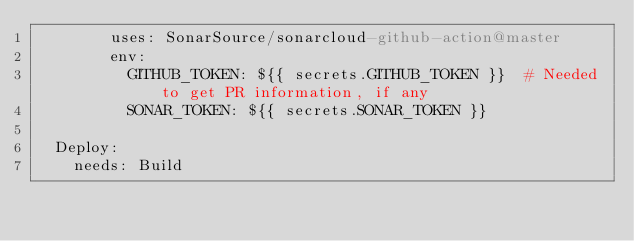<code> <loc_0><loc_0><loc_500><loc_500><_YAML_>        uses: SonarSource/sonarcloud-github-action@master
        env:
          GITHUB_TOKEN: ${{ secrets.GITHUB_TOKEN }}  # Needed to get PR information, if any
          SONAR_TOKEN: ${{ secrets.SONAR_TOKEN }}

  Deploy:
    needs: Build</code> 